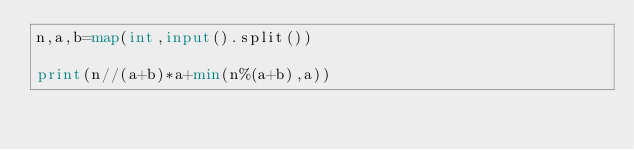Convert code to text. <code><loc_0><loc_0><loc_500><loc_500><_Python_>n,a,b=map(int,input().split())

print(n//(a+b)*a+min(n%(a+b),a))</code> 